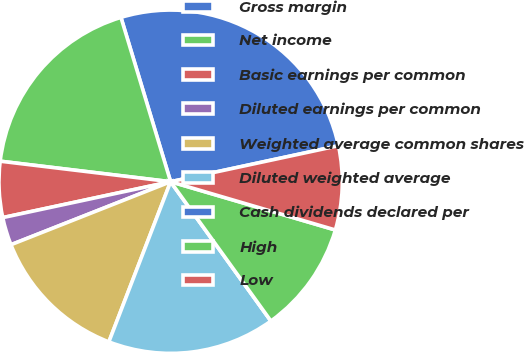Convert chart. <chart><loc_0><loc_0><loc_500><loc_500><pie_chart><fcel>Gross margin<fcel>Net income<fcel>Basic earnings per common<fcel>Diluted earnings per common<fcel>Weighted average common shares<fcel>Diluted weighted average<fcel>Cash dividends declared per<fcel>High<fcel>Low<nl><fcel>26.31%<fcel>18.42%<fcel>5.26%<fcel>2.63%<fcel>13.16%<fcel>15.79%<fcel>0.0%<fcel>10.53%<fcel>7.9%<nl></chart> 